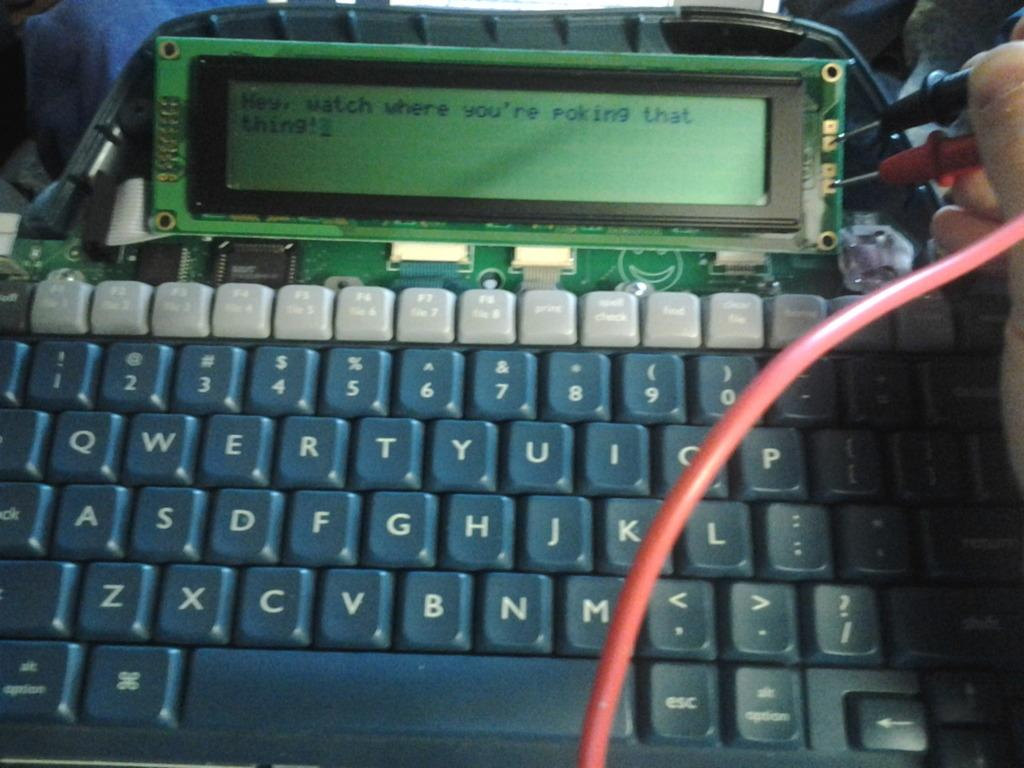<image>
Offer a succinct explanation of the picture presented. A computer read out warns a person to watch where they're poking. 